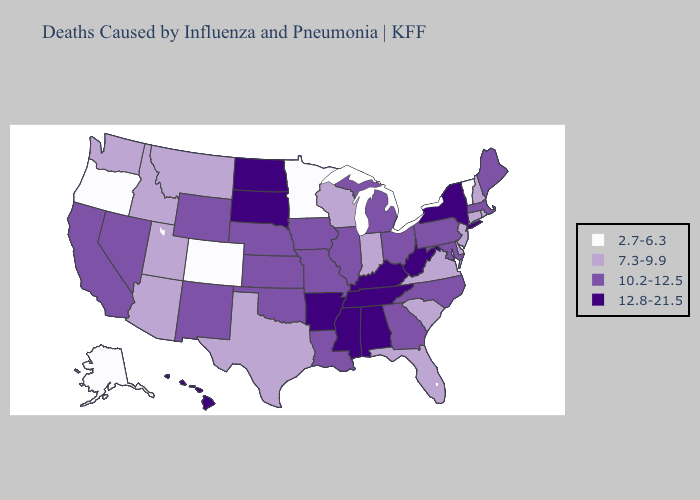Among the states that border California , does Oregon have the lowest value?
Answer briefly. Yes. Does Arkansas have the lowest value in the South?
Write a very short answer. No. Name the states that have a value in the range 12.8-21.5?
Give a very brief answer. Alabama, Arkansas, Hawaii, Kentucky, Mississippi, New York, North Dakota, South Dakota, Tennessee, West Virginia. Name the states that have a value in the range 2.7-6.3?
Write a very short answer. Alaska, Colorado, Minnesota, Oregon, Vermont. What is the value of Alabama?
Keep it brief. 12.8-21.5. What is the value of South Carolina?
Be succinct. 7.3-9.9. Among the states that border Minnesota , does North Dakota have the highest value?
Keep it brief. Yes. Which states have the lowest value in the USA?
Short answer required. Alaska, Colorado, Minnesota, Oregon, Vermont. Name the states that have a value in the range 7.3-9.9?
Give a very brief answer. Arizona, Connecticut, Delaware, Florida, Idaho, Indiana, Montana, New Hampshire, New Jersey, Rhode Island, South Carolina, Texas, Utah, Virginia, Washington, Wisconsin. What is the value of South Carolina?
Be succinct. 7.3-9.9. Among the states that border Idaho , which have the highest value?
Write a very short answer. Nevada, Wyoming. Name the states that have a value in the range 7.3-9.9?
Short answer required. Arizona, Connecticut, Delaware, Florida, Idaho, Indiana, Montana, New Hampshire, New Jersey, Rhode Island, South Carolina, Texas, Utah, Virginia, Washington, Wisconsin. What is the lowest value in states that border Wyoming?
Be succinct. 2.7-6.3. Which states have the lowest value in the MidWest?
Quick response, please. Minnesota. 